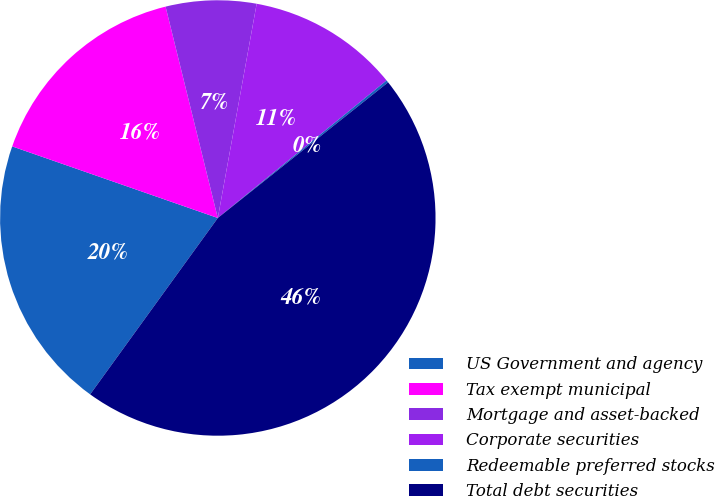Convert chart to OTSL. <chart><loc_0><loc_0><loc_500><loc_500><pie_chart><fcel>US Government and agency<fcel>Tax exempt municipal<fcel>Mortgage and asset-backed<fcel>Corporate securities<fcel>Redeemable preferred stocks<fcel>Total debt securities<nl><fcel>20.36%<fcel>15.81%<fcel>6.71%<fcel>11.26%<fcel>0.18%<fcel>45.67%<nl></chart> 